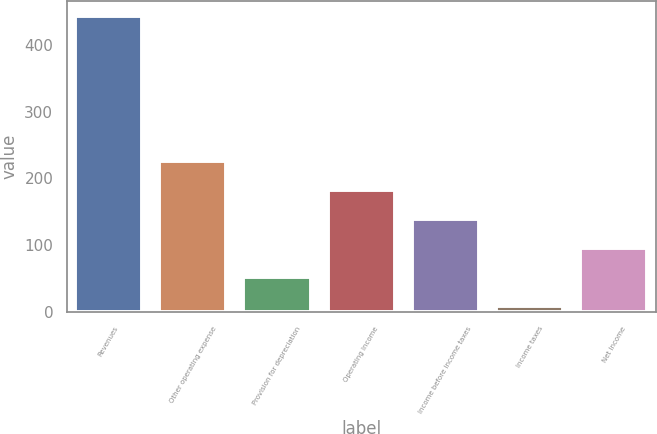<chart> <loc_0><loc_0><loc_500><loc_500><bar_chart><fcel>Revenues<fcel>Other operating expense<fcel>Provision for depreciation<fcel>Operating Income<fcel>Income before income taxes<fcel>Income taxes<fcel>Net Income<nl><fcel>442.7<fcel>226.4<fcel>53.36<fcel>183.14<fcel>139.88<fcel>10.1<fcel>96.62<nl></chart> 